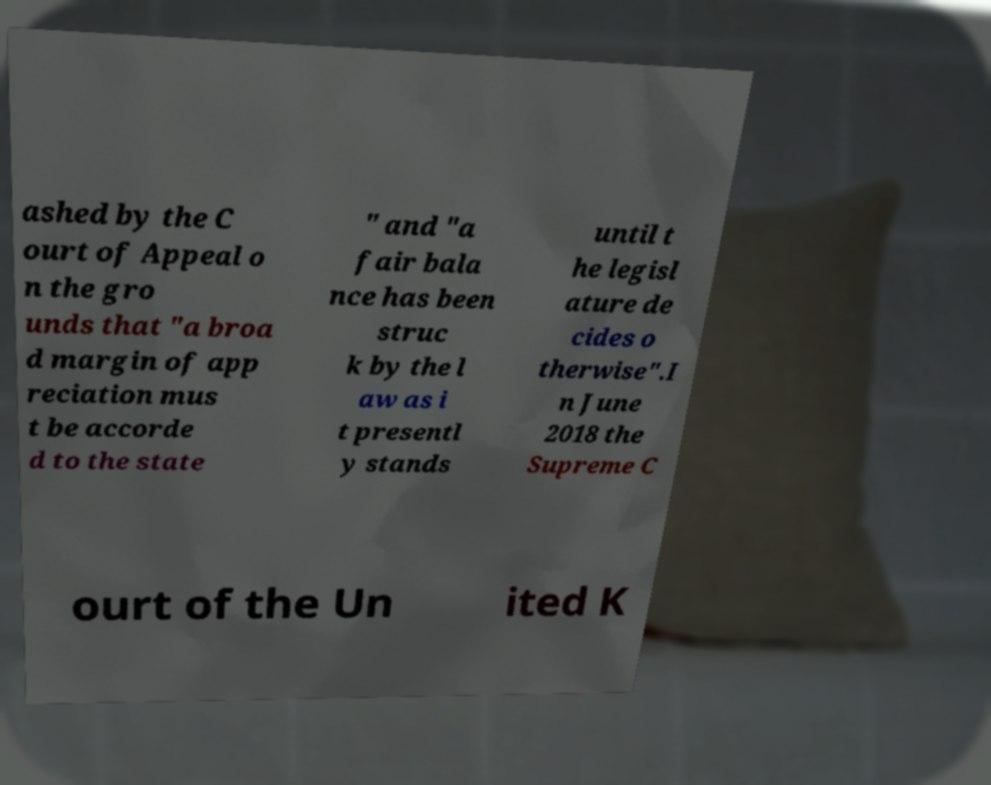Could you extract and type out the text from this image? ashed by the C ourt of Appeal o n the gro unds that "a broa d margin of app reciation mus t be accorde d to the state " and "a fair bala nce has been struc k by the l aw as i t presentl y stands until t he legisl ature de cides o therwise".I n June 2018 the Supreme C ourt of the Un ited K 